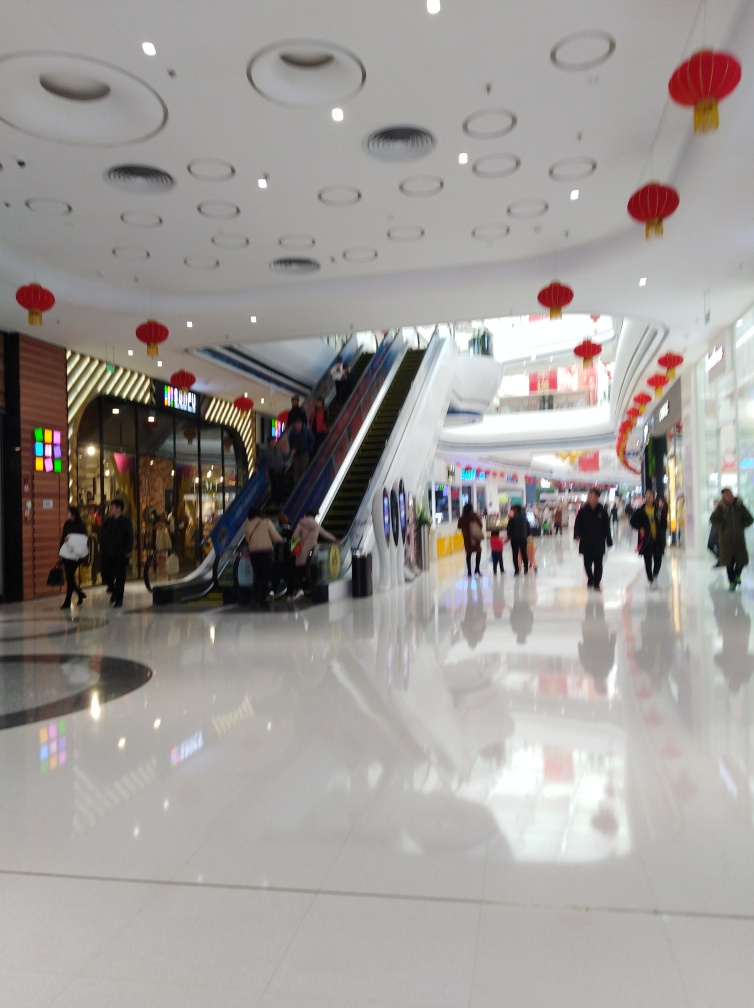What has caused a loss of texture details in the image? Upon reviewing the image, it appears that the blurring effect, especially noticeable on the moving figures and surrounding areas, has resulted in a loss of texture details. This effect might be due to motion blur or a low shutter speed used while capturing the image, which causes moving objects to appear blurred and consequently, lose detail in texture. 